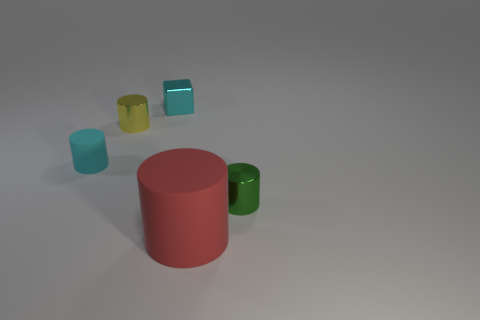Subtract all blue cylinders. Subtract all red blocks. How many cylinders are left? 4 Add 5 tiny brown things. How many objects exist? 10 Subtract all cylinders. How many objects are left? 1 Add 4 cubes. How many cubes are left? 5 Add 5 purple metal spheres. How many purple metal spheres exist? 5 Subtract 0 green balls. How many objects are left? 5 Subtract all large objects. Subtract all matte cylinders. How many objects are left? 2 